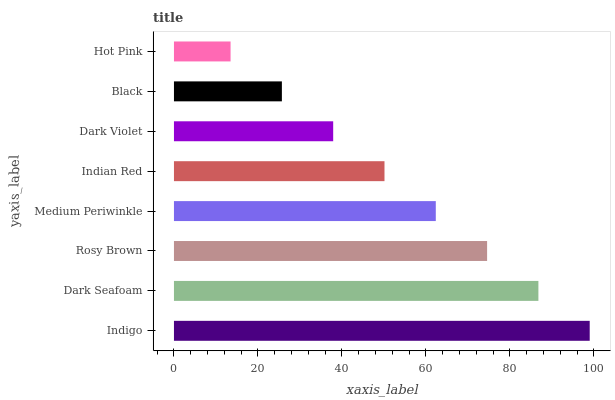Is Hot Pink the minimum?
Answer yes or no. Yes. Is Indigo the maximum?
Answer yes or no. Yes. Is Dark Seafoam the minimum?
Answer yes or no. No. Is Dark Seafoam the maximum?
Answer yes or no. No. Is Indigo greater than Dark Seafoam?
Answer yes or no. Yes. Is Dark Seafoam less than Indigo?
Answer yes or no. Yes. Is Dark Seafoam greater than Indigo?
Answer yes or no. No. Is Indigo less than Dark Seafoam?
Answer yes or no. No. Is Medium Periwinkle the high median?
Answer yes or no. Yes. Is Indian Red the low median?
Answer yes or no. Yes. Is Indigo the high median?
Answer yes or no. No. Is Rosy Brown the low median?
Answer yes or no. No. 